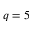<formula> <loc_0><loc_0><loc_500><loc_500>q = 5</formula> 